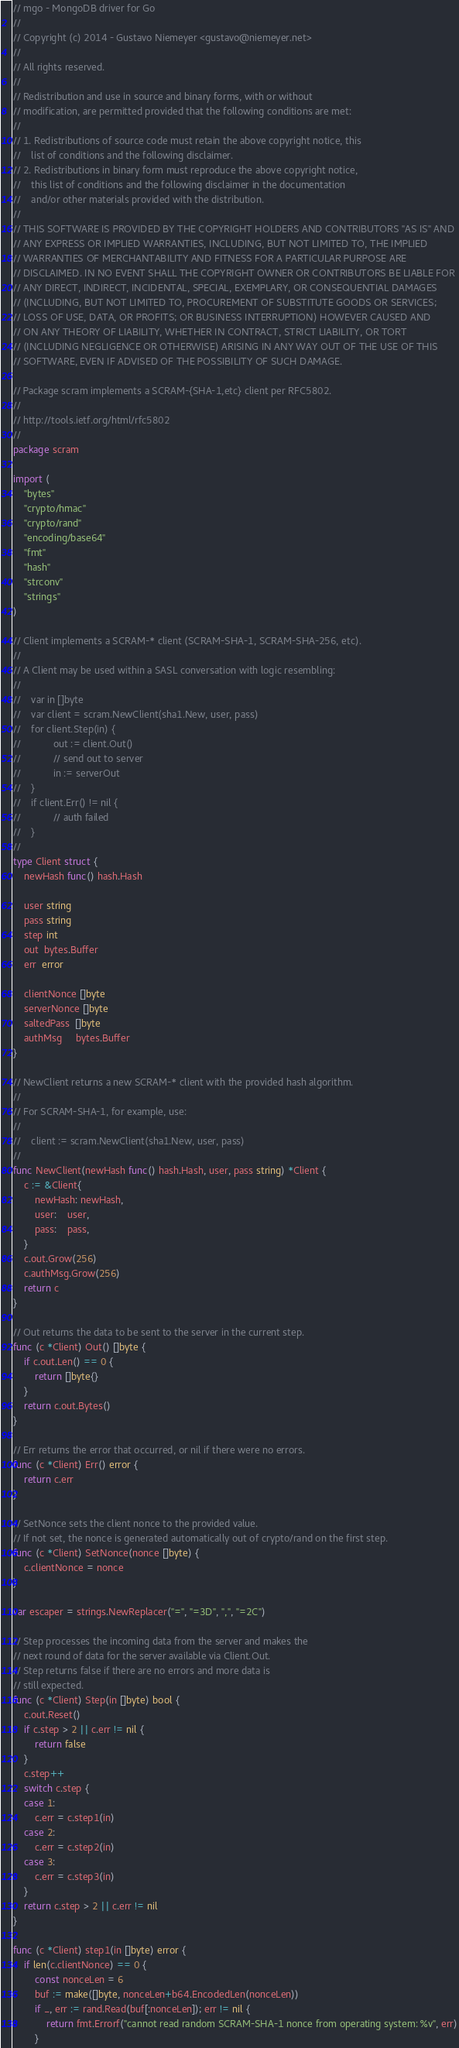<code> <loc_0><loc_0><loc_500><loc_500><_Go_>// mgo - MongoDB driver for Go
//
// Copyright (c) 2014 - Gustavo Niemeyer <gustavo@niemeyer.net>
//
// All rights reserved.
//
// Redistribution and use in source and binary forms, with or without
// modification, are permitted provided that the following conditions are met:
//
// 1. Redistributions of source code must retain the above copyright notice, this
//    list of conditions and the following disclaimer.
// 2. Redistributions in binary form must reproduce the above copyright notice,
//    this list of conditions and the following disclaimer in the documentation
//    and/or other materials provided with the distribution.
//
// THIS SOFTWARE IS PROVIDED BY THE COPYRIGHT HOLDERS AND CONTRIBUTORS "AS IS" AND
// ANY EXPRESS OR IMPLIED WARRANTIES, INCLUDING, BUT NOT LIMITED TO, THE IMPLIED
// WARRANTIES OF MERCHANTABILITY AND FITNESS FOR A PARTICULAR PURPOSE ARE
// DISCLAIMED. IN NO EVENT SHALL THE COPYRIGHT OWNER OR CONTRIBUTORS BE LIABLE FOR
// ANY DIRECT, INDIRECT, INCIDENTAL, SPECIAL, EXEMPLARY, OR CONSEQUENTIAL DAMAGES
// (INCLUDING, BUT NOT LIMITED TO, PROCUREMENT OF SUBSTITUTE GOODS OR SERVICES;
// LOSS OF USE, DATA, OR PROFITS; OR BUSINESS INTERRUPTION) HOWEVER CAUSED AND
// ON ANY THEORY OF LIABILITY, WHETHER IN CONTRACT, STRICT LIABILITY, OR TORT
// (INCLUDING NEGLIGENCE OR OTHERWISE) ARISING IN ANY WAY OUT OF THE USE OF THIS
// SOFTWARE, EVEN IF ADVISED OF THE POSSIBILITY OF SUCH DAMAGE.

// Package scram implements a SCRAM-{SHA-1,etc} client per RFC5802.
//
// http://tools.ietf.org/html/rfc5802
//
package scram

import (
	"bytes"
	"crypto/hmac"
	"crypto/rand"
	"encoding/base64"
	"fmt"
	"hash"
	"strconv"
	"strings"
)

// Client implements a SCRAM-* client (SCRAM-SHA-1, SCRAM-SHA-256, etc).
//
// A Client may be used within a SASL conversation with logic resembling:
//
//    var in []byte
//    var client = scram.NewClient(sha1.New, user, pass)
//    for client.Step(in) {
//            out := client.Out()
//            // send out to server
//            in := serverOut
//    }
//    if client.Err() != nil {
//            // auth failed
//    }
//
type Client struct {
	newHash func() hash.Hash

	user string
	pass string
	step int
	out  bytes.Buffer
	err  error

	clientNonce []byte
	serverNonce []byte
	saltedPass  []byte
	authMsg     bytes.Buffer
}

// NewClient returns a new SCRAM-* client with the provided hash algorithm.
//
// For SCRAM-SHA-1, for example, use:
//
//    client := scram.NewClient(sha1.New, user, pass)
//
func NewClient(newHash func() hash.Hash, user, pass string) *Client {
	c := &Client{
		newHash: newHash,
		user:    user,
		pass:    pass,
	}
	c.out.Grow(256)
	c.authMsg.Grow(256)
	return c
}

// Out returns the data to be sent to the server in the current step.
func (c *Client) Out() []byte {
	if c.out.Len() == 0 {
		return []byte{}
	}
	return c.out.Bytes()
}

// Err returns the error that occurred, or nil if there were no errors.
func (c *Client) Err() error {
	return c.err
}

// SetNonce sets the client nonce to the provided value.
// If not set, the nonce is generated automatically out of crypto/rand on the first step.
func (c *Client) SetNonce(nonce []byte) {
	c.clientNonce = nonce
}

var escaper = strings.NewReplacer("=", "=3D", ",", "=2C")

// Step processes the incoming data from the server and makes the
// next round of data for the server available via Client.Out.
// Step returns false if there are no errors and more data is
// still expected.
func (c *Client) Step(in []byte) bool {
	c.out.Reset()
	if c.step > 2 || c.err != nil {
		return false
	}
	c.step++
	switch c.step {
	case 1:
		c.err = c.step1(in)
	case 2:
		c.err = c.step2(in)
	case 3:
		c.err = c.step3(in)
	}
	return c.step > 2 || c.err != nil
}

func (c *Client) step1(in []byte) error {
	if len(c.clientNonce) == 0 {
		const nonceLen = 6
		buf := make([]byte, nonceLen+b64.EncodedLen(nonceLen))
		if _, err := rand.Read(buf[:nonceLen]); err != nil {
			return fmt.Errorf("cannot read random SCRAM-SHA-1 nonce from operating system: %v", err)
		}</code> 